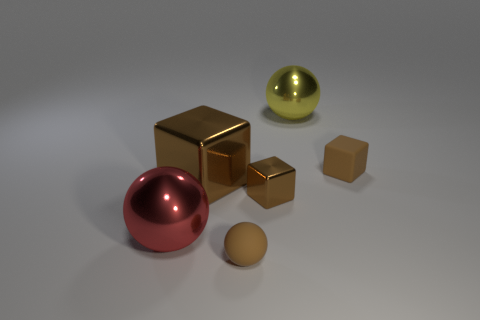There is a block that is the same size as the yellow object; what is its color?
Ensure brevity in your answer.  Brown. There is a brown matte thing that is the same shape as the red shiny thing; what is its size?
Offer a terse response. Small. There is a brown rubber object that is to the left of the big yellow metallic ball; what shape is it?
Your answer should be compact. Sphere. Does the big red shiny thing have the same shape as the brown object behind the large brown object?
Ensure brevity in your answer.  No. Are there the same number of yellow objects in front of the yellow shiny object and yellow metal objects that are to the left of the tiny brown rubber sphere?
Ensure brevity in your answer.  Yes. What is the shape of the large metal thing that is the same color as the tiny ball?
Give a very brief answer. Cube. There is a thing in front of the large red object; does it have the same color as the small matte object that is behind the big red shiny ball?
Keep it short and to the point. Yes. Is the number of brown metal blocks that are on the right side of the big metallic cube greater than the number of cyan spheres?
Offer a terse response. Yes. What is the brown sphere made of?
Give a very brief answer. Rubber. There is a large yellow thing that is made of the same material as the large brown cube; what is its shape?
Your response must be concise. Sphere. 